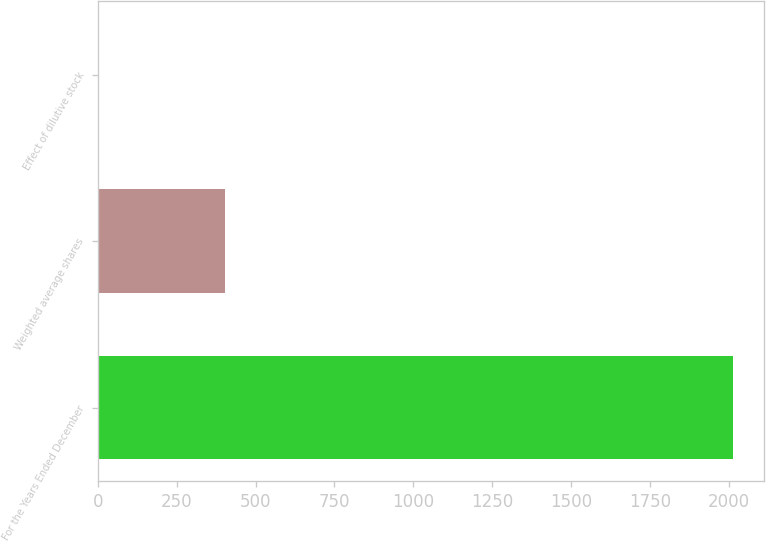Convert chart. <chart><loc_0><loc_0><loc_500><loc_500><bar_chart><fcel>For the Years Ended December<fcel>Weighted average shares<fcel>Effect of dilutive stock<nl><fcel>2013<fcel>404.36<fcel>2.2<nl></chart> 